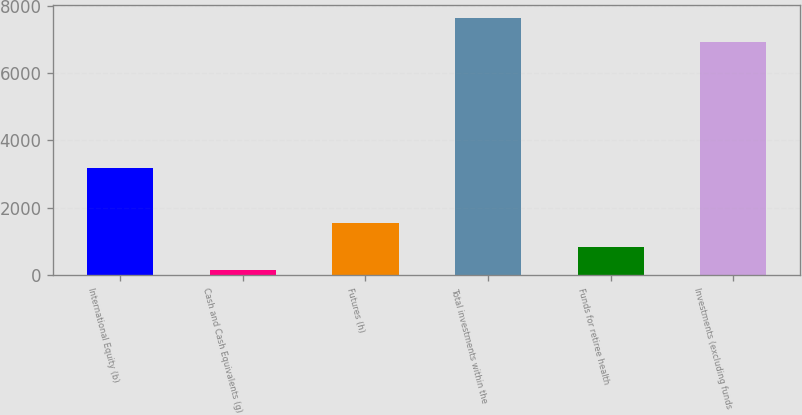<chart> <loc_0><loc_0><loc_500><loc_500><bar_chart><fcel>International Equity (b)<fcel>Cash and Cash Equivalents (g)<fcel>Futures (h)<fcel>Total investments within the<fcel>Funds for retiree health<fcel>Investments (excluding funds<nl><fcel>3187<fcel>147<fcel>1536.8<fcel>7625.9<fcel>841.9<fcel>6931<nl></chart> 